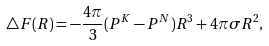<formula> <loc_0><loc_0><loc_500><loc_500>\triangle F ( R ) = - \frac { 4 \pi } { 3 } ( P ^ { K } - P ^ { N } ) R ^ { 3 } + 4 \pi \sigma R ^ { 2 } ,</formula> 